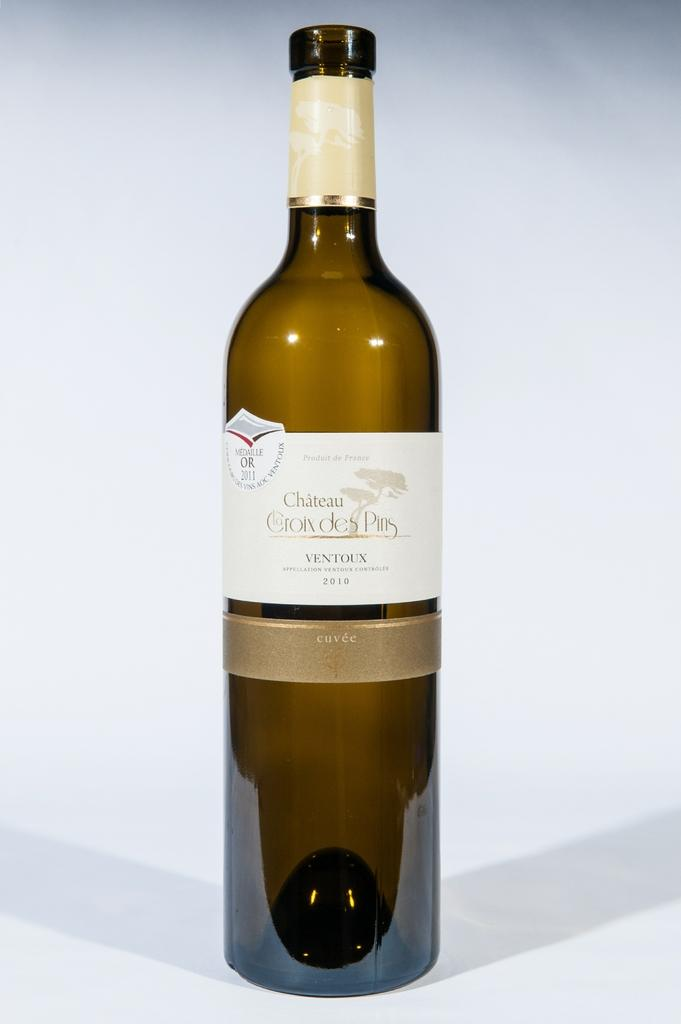<image>
Give a short and clear explanation of the subsequent image. A bottle of wine has both the year 2010 and the year 2011 on its label. 